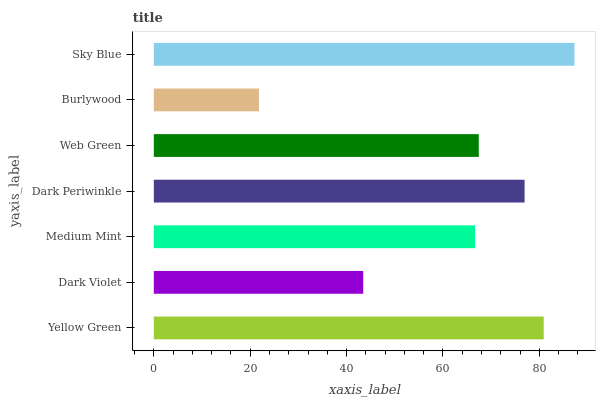Is Burlywood the minimum?
Answer yes or no. Yes. Is Sky Blue the maximum?
Answer yes or no. Yes. Is Dark Violet the minimum?
Answer yes or no. No. Is Dark Violet the maximum?
Answer yes or no. No. Is Yellow Green greater than Dark Violet?
Answer yes or no. Yes. Is Dark Violet less than Yellow Green?
Answer yes or no. Yes. Is Dark Violet greater than Yellow Green?
Answer yes or no. No. Is Yellow Green less than Dark Violet?
Answer yes or no. No. Is Web Green the high median?
Answer yes or no. Yes. Is Web Green the low median?
Answer yes or no. Yes. Is Dark Violet the high median?
Answer yes or no. No. Is Medium Mint the low median?
Answer yes or no. No. 